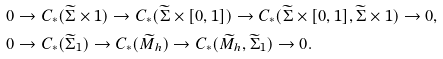Convert formula to latex. <formula><loc_0><loc_0><loc_500><loc_500>& 0 \to C _ { * } ( \widetilde { \Sigma } \times 1 ) \to C _ { * } ( \widetilde { \Sigma } \times [ 0 , 1 ] ) \to C _ { * } ( \widetilde { \Sigma } \times [ 0 , 1 ] , \widetilde { \Sigma } \times 1 ) \to 0 , \\ & 0 \to C _ { * } ( \widetilde { \Sigma } _ { 1 } ) \to C _ { * } ( \widetilde { M } _ { h } ) \to C _ { * } ( \widetilde { M } _ { h } , \widetilde { \Sigma } _ { 1 } ) \to 0 .</formula> 